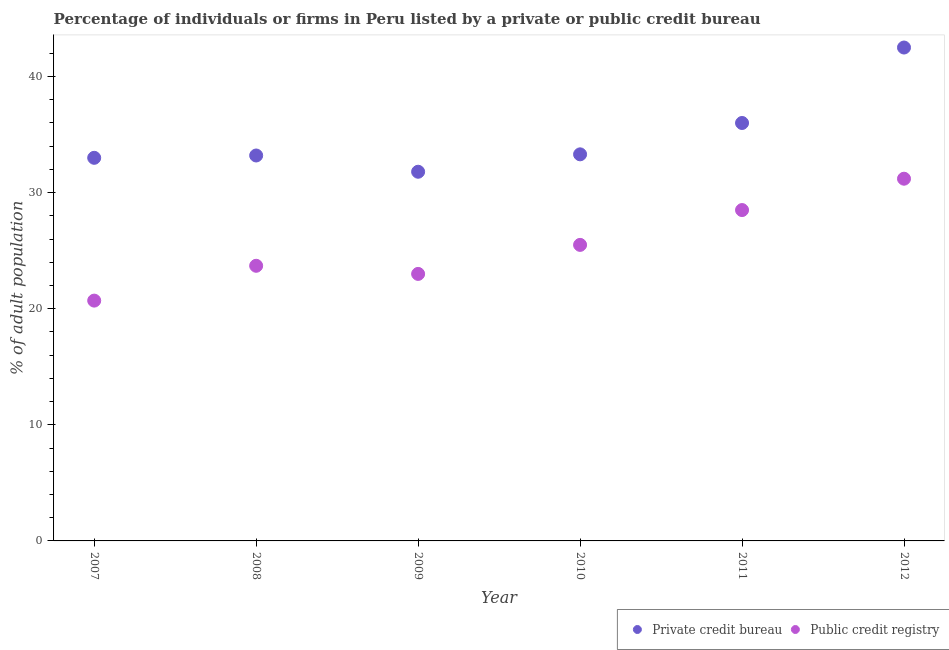How many different coloured dotlines are there?
Ensure brevity in your answer.  2. Is the number of dotlines equal to the number of legend labels?
Make the answer very short. Yes. What is the percentage of firms listed by private credit bureau in 2007?
Provide a short and direct response. 33. Across all years, what is the maximum percentage of firms listed by public credit bureau?
Make the answer very short. 31.2. Across all years, what is the minimum percentage of firms listed by public credit bureau?
Give a very brief answer. 20.7. In which year was the percentage of firms listed by private credit bureau minimum?
Offer a terse response. 2009. What is the total percentage of firms listed by private credit bureau in the graph?
Your answer should be very brief. 209.8. What is the difference between the percentage of firms listed by private credit bureau in 2007 and that in 2008?
Ensure brevity in your answer.  -0.2. What is the difference between the percentage of firms listed by public credit bureau in 2007 and the percentage of firms listed by private credit bureau in 2008?
Provide a short and direct response. -12.5. What is the average percentage of firms listed by public credit bureau per year?
Provide a short and direct response. 25.43. In the year 2011, what is the difference between the percentage of firms listed by public credit bureau and percentage of firms listed by private credit bureau?
Provide a short and direct response. -7.5. What is the ratio of the percentage of firms listed by public credit bureau in 2007 to that in 2008?
Offer a very short reply. 0.87. What is the difference between the highest and the second highest percentage of firms listed by private credit bureau?
Your answer should be compact. 6.5. In how many years, is the percentage of firms listed by public credit bureau greater than the average percentage of firms listed by public credit bureau taken over all years?
Your response must be concise. 3. Is the sum of the percentage of firms listed by public credit bureau in 2010 and 2011 greater than the maximum percentage of firms listed by private credit bureau across all years?
Offer a very short reply. Yes. Is the percentage of firms listed by private credit bureau strictly less than the percentage of firms listed by public credit bureau over the years?
Make the answer very short. No. Are the values on the major ticks of Y-axis written in scientific E-notation?
Ensure brevity in your answer.  No. Does the graph contain grids?
Provide a short and direct response. No. What is the title of the graph?
Your answer should be very brief. Percentage of individuals or firms in Peru listed by a private or public credit bureau. What is the label or title of the X-axis?
Offer a very short reply. Year. What is the label or title of the Y-axis?
Make the answer very short. % of adult population. What is the % of adult population of Public credit registry in 2007?
Keep it short and to the point. 20.7. What is the % of adult population of Private credit bureau in 2008?
Your answer should be very brief. 33.2. What is the % of adult population in Public credit registry in 2008?
Provide a succinct answer. 23.7. What is the % of adult population in Private credit bureau in 2009?
Keep it short and to the point. 31.8. What is the % of adult population of Public credit registry in 2009?
Give a very brief answer. 23. What is the % of adult population in Private credit bureau in 2010?
Provide a succinct answer. 33.3. What is the % of adult population of Public credit registry in 2011?
Offer a very short reply. 28.5. What is the % of adult population in Private credit bureau in 2012?
Provide a succinct answer. 42.5. What is the % of adult population in Public credit registry in 2012?
Your response must be concise. 31.2. Across all years, what is the maximum % of adult population in Private credit bureau?
Keep it short and to the point. 42.5. Across all years, what is the maximum % of adult population of Public credit registry?
Provide a short and direct response. 31.2. Across all years, what is the minimum % of adult population in Private credit bureau?
Offer a terse response. 31.8. Across all years, what is the minimum % of adult population of Public credit registry?
Provide a short and direct response. 20.7. What is the total % of adult population of Private credit bureau in the graph?
Your response must be concise. 209.8. What is the total % of adult population of Public credit registry in the graph?
Give a very brief answer. 152.6. What is the difference between the % of adult population of Public credit registry in 2007 and that in 2008?
Your answer should be compact. -3. What is the difference between the % of adult population of Public credit registry in 2007 and that in 2011?
Offer a terse response. -7.8. What is the difference between the % of adult population in Public credit registry in 2008 and that in 2009?
Your response must be concise. 0.7. What is the difference between the % of adult population of Private credit bureau in 2008 and that in 2010?
Give a very brief answer. -0.1. What is the difference between the % of adult population of Public credit registry in 2008 and that in 2010?
Your answer should be very brief. -1.8. What is the difference between the % of adult population in Private credit bureau in 2008 and that in 2012?
Provide a short and direct response. -9.3. What is the difference between the % of adult population in Private credit bureau in 2009 and that in 2010?
Give a very brief answer. -1.5. What is the difference between the % of adult population of Public credit registry in 2009 and that in 2010?
Your response must be concise. -2.5. What is the difference between the % of adult population in Private credit bureau in 2009 and that in 2011?
Ensure brevity in your answer.  -4.2. What is the difference between the % of adult population of Public credit registry in 2009 and that in 2011?
Make the answer very short. -5.5. What is the difference between the % of adult population in Private credit bureau in 2009 and that in 2012?
Provide a succinct answer. -10.7. What is the difference between the % of adult population in Public credit registry in 2009 and that in 2012?
Keep it short and to the point. -8.2. What is the difference between the % of adult population of Private credit bureau in 2010 and that in 2011?
Offer a terse response. -2.7. What is the difference between the % of adult population in Public credit registry in 2010 and that in 2011?
Ensure brevity in your answer.  -3. What is the difference between the % of adult population of Public credit registry in 2010 and that in 2012?
Ensure brevity in your answer.  -5.7. What is the difference between the % of adult population of Private credit bureau in 2007 and the % of adult population of Public credit registry in 2008?
Ensure brevity in your answer.  9.3. What is the difference between the % of adult population in Private credit bureau in 2007 and the % of adult population in Public credit registry in 2009?
Your response must be concise. 10. What is the difference between the % of adult population of Private credit bureau in 2007 and the % of adult population of Public credit registry in 2010?
Ensure brevity in your answer.  7.5. What is the difference between the % of adult population of Private credit bureau in 2007 and the % of adult population of Public credit registry in 2011?
Offer a terse response. 4.5. What is the difference between the % of adult population of Private credit bureau in 2008 and the % of adult population of Public credit registry in 2010?
Make the answer very short. 7.7. What is the difference between the % of adult population of Private credit bureau in 2008 and the % of adult population of Public credit registry in 2011?
Keep it short and to the point. 4.7. What is the difference between the % of adult population in Private credit bureau in 2009 and the % of adult population in Public credit registry in 2010?
Provide a short and direct response. 6.3. What is the difference between the % of adult population of Private credit bureau in 2010 and the % of adult population of Public credit registry in 2011?
Keep it short and to the point. 4.8. What is the average % of adult population of Private credit bureau per year?
Keep it short and to the point. 34.97. What is the average % of adult population of Public credit registry per year?
Your answer should be very brief. 25.43. In the year 2007, what is the difference between the % of adult population in Private credit bureau and % of adult population in Public credit registry?
Provide a succinct answer. 12.3. In the year 2008, what is the difference between the % of adult population of Private credit bureau and % of adult population of Public credit registry?
Provide a short and direct response. 9.5. What is the ratio of the % of adult population of Private credit bureau in 2007 to that in 2008?
Your response must be concise. 0.99. What is the ratio of the % of adult population of Public credit registry in 2007 to that in 2008?
Offer a very short reply. 0.87. What is the ratio of the % of adult population of Private credit bureau in 2007 to that in 2009?
Offer a very short reply. 1.04. What is the ratio of the % of adult population of Public credit registry in 2007 to that in 2009?
Ensure brevity in your answer.  0.9. What is the ratio of the % of adult population of Public credit registry in 2007 to that in 2010?
Offer a terse response. 0.81. What is the ratio of the % of adult population in Private credit bureau in 2007 to that in 2011?
Your answer should be compact. 0.92. What is the ratio of the % of adult population in Public credit registry in 2007 to that in 2011?
Your answer should be very brief. 0.73. What is the ratio of the % of adult population in Private credit bureau in 2007 to that in 2012?
Offer a very short reply. 0.78. What is the ratio of the % of adult population in Public credit registry in 2007 to that in 2012?
Provide a succinct answer. 0.66. What is the ratio of the % of adult population of Private credit bureau in 2008 to that in 2009?
Provide a succinct answer. 1.04. What is the ratio of the % of adult population in Public credit registry in 2008 to that in 2009?
Provide a short and direct response. 1.03. What is the ratio of the % of adult population in Public credit registry in 2008 to that in 2010?
Offer a terse response. 0.93. What is the ratio of the % of adult population in Private credit bureau in 2008 to that in 2011?
Ensure brevity in your answer.  0.92. What is the ratio of the % of adult population in Public credit registry in 2008 to that in 2011?
Offer a very short reply. 0.83. What is the ratio of the % of adult population in Private credit bureau in 2008 to that in 2012?
Your answer should be compact. 0.78. What is the ratio of the % of adult population in Public credit registry in 2008 to that in 2012?
Keep it short and to the point. 0.76. What is the ratio of the % of adult population of Private credit bureau in 2009 to that in 2010?
Offer a terse response. 0.95. What is the ratio of the % of adult population of Public credit registry in 2009 to that in 2010?
Provide a short and direct response. 0.9. What is the ratio of the % of adult population of Private credit bureau in 2009 to that in 2011?
Keep it short and to the point. 0.88. What is the ratio of the % of adult population in Public credit registry in 2009 to that in 2011?
Your response must be concise. 0.81. What is the ratio of the % of adult population in Private credit bureau in 2009 to that in 2012?
Your answer should be very brief. 0.75. What is the ratio of the % of adult population in Public credit registry in 2009 to that in 2012?
Offer a very short reply. 0.74. What is the ratio of the % of adult population of Private credit bureau in 2010 to that in 2011?
Provide a short and direct response. 0.93. What is the ratio of the % of adult population in Public credit registry in 2010 to that in 2011?
Your answer should be very brief. 0.89. What is the ratio of the % of adult population in Private credit bureau in 2010 to that in 2012?
Provide a succinct answer. 0.78. What is the ratio of the % of adult population in Public credit registry in 2010 to that in 2012?
Your response must be concise. 0.82. What is the ratio of the % of adult population in Private credit bureau in 2011 to that in 2012?
Your answer should be compact. 0.85. What is the ratio of the % of adult population of Public credit registry in 2011 to that in 2012?
Offer a terse response. 0.91. What is the difference between the highest and the second highest % of adult population of Private credit bureau?
Provide a succinct answer. 6.5. 